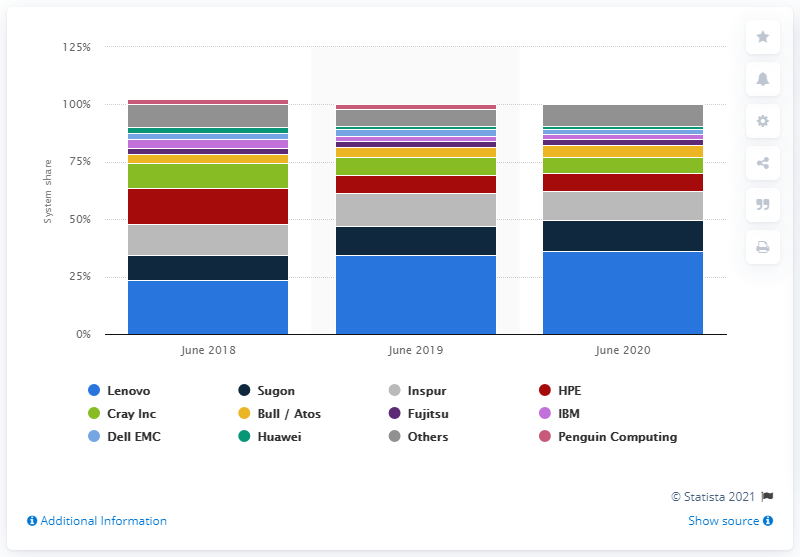Outline some significant characteristics in this image. Sugon was the second-ranked vendor in terms of system share of the top 500 supercomputers globally, according to the latest data available. In June 2020, Lenovo ranked first among vendors in terms of system share of the top 500 supercomputers worldwide. 